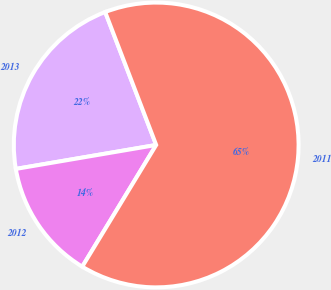<chart> <loc_0><loc_0><loc_500><loc_500><pie_chart><fcel>2013<fcel>2012<fcel>2011<nl><fcel>21.86%<fcel>13.62%<fcel>64.52%<nl></chart> 